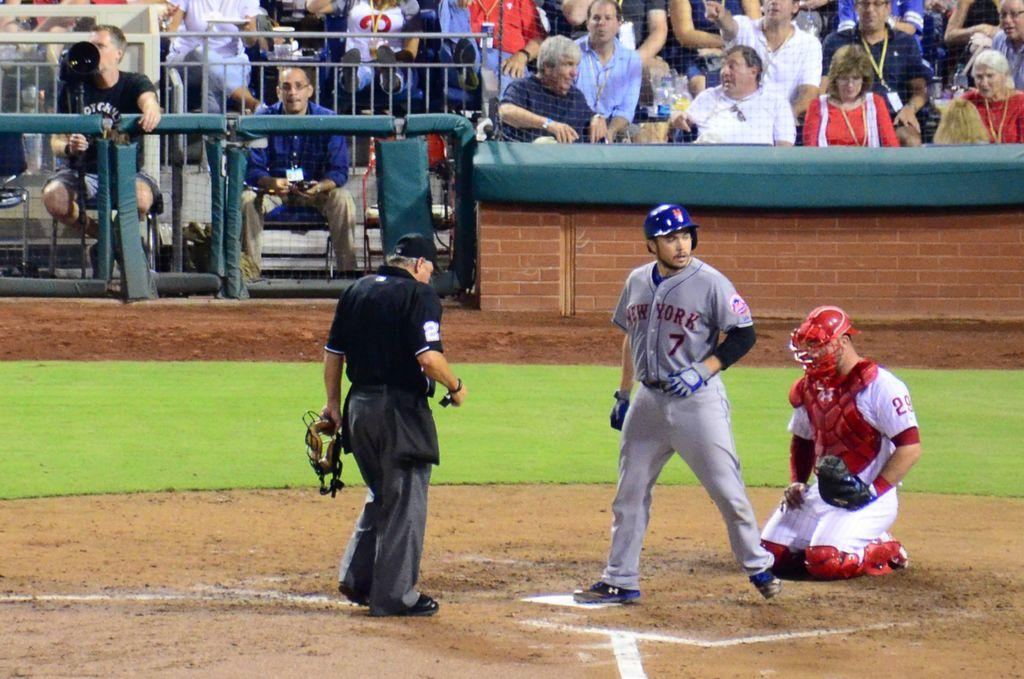<image>
Create a compact narrative representing the image presented. The player from the New York team wears a number 7 on his top. 